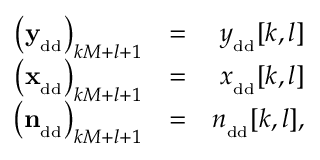Convert formula to latex. <formula><loc_0><loc_0><loc_500><loc_500>\begin{array} { r l r } { \left ( { y } _ { _ { d d } } \right ) _ { k M + l + 1 } } & { = } & { { y } _ { _ { d d } } [ k , l ] } \\ { \left ( { x } _ { _ { d d } } \right ) _ { k M + l + 1 } } & { = } & { { x } _ { _ { d d } } [ k , l ] } \\ { \, \left ( { n } _ { _ { d d } } \right ) _ { k M + l + 1 } } & { = } & { { n } _ { _ { d d } } [ k , l ] , } \end{array}</formula> 